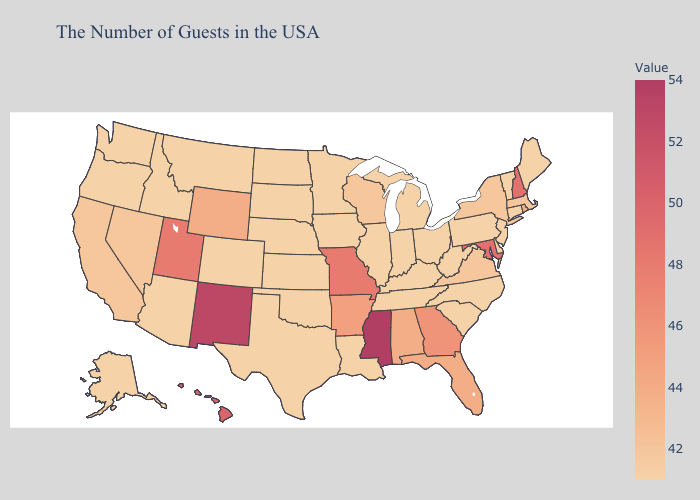Does the map have missing data?
Answer briefly. No. Which states have the lowest value in the USA?
Concise answer only. Maine, Vermont, Connecticut, New Jersey, Delaware, Pennsylvania, North Carolina, South Carolina, West Virginia, Ohio, Michigan, Kentucky, Indiana, Tennessee, Illinois, Louisiana, Minnesota, Iowa, Kansas, Nebraska, Oklahoma, Texas, South Dakota, North Dakota, Colorado, Montana, Arizona, Idaho, Washington, Oregon, Alaska. Does Maine have the lowest value in the USA?
Quick response, please. Yes. Does the map have missing data?
Give a very brief answer. No. Does the map have missing data?
Keep it brief. No. Among the states that border Florida , which have the highest value?
Concise answer only. Georgia. Among the states that border Delaware , which have the highest value?
Write a very short answer. Maryland. 